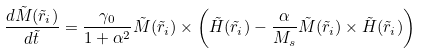Convert formula to latex. <formula><loc_0><loc_0><loc_500><loc_500>\frac { { d } { \tilde { M } } ( { \tilde { r } } _ { i } ) } { { d } \tilde { t } } = \frac { \gamma _ { 0 } } { 1 + \alpha ^ { 2 } } { \tilde { M } } ( { \tilde { r } } _ { i } ) \times \left ( { \tilde { H } } ( { \tilde { r } } _ { i } ) - \frac { \alpha } { M _ { s } } { \tilde { M } } ( { \tilde { r } } _ { i } ) \times { \tilde { H } } ( { \tilde { r } } _ { i } ) \right ) \,</formula> 